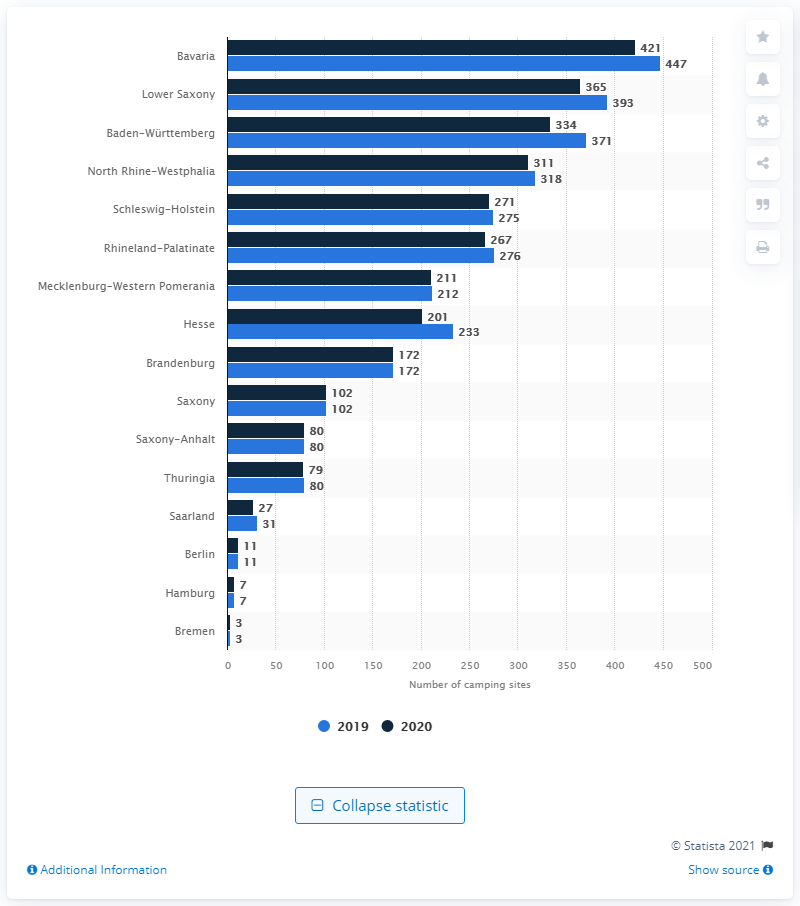How has the number of camping sites in Bavaria changed from 2019 to 2020? From 2019 to 2020, the number of camping sites in Bavaria increased, indicating a growth in camping infrastructure and possibly a rising interest in outdoor tourism within the region. Can you tell me more about what makes Bavaria an attractive camping destination? Bavaria is known for its breathtaking natural beauty, featuring the majestic Alps, deep forests, and the scenic Danube River. It's also culturally rich, with traditional festivals and historic sites, making it a diverse and appealing option for those looking to explore Germany's natural and cultural offerings while camping. 